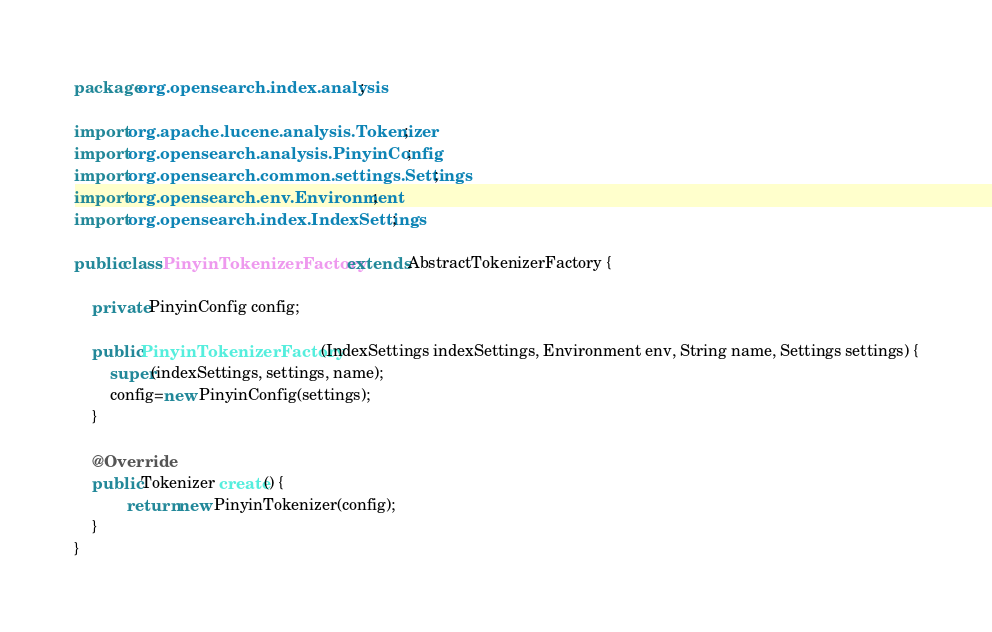<code> <loc_0><loc_0><loc_500><loc_500><_Java_>package org.opensearch.index.analysis;

import org.apache.lucene.analysis.Tokenizer;
import org.opensearch.analysis.PinyinConfig;
import org.opensearch.common.settings.Settings;
import org.opensearch.env.Environment;
import org.opensearch.index.IndexSettings;

public class PinyinTokenizerFactory extends AbstractTokenizerFactory {

    private PinyinConfig config;

    public PinyinTokenizerFactory(IndexSettings indexSettings, Environment env, String name, Settings settings) {
        super(indexSettings, settings, name);
        config=new PinyinConfig(settings);
    }

    @Override
    public Tokenizer create() {
            return new PinyinTokenizer(config);
    }
}

</code> 